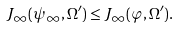Convert formula to latex. <formula><loc_0><loc_0><loc_500><loc_500>J _ { \infty } ( \psi _ { \infty } , \Omega ^ { \prime } ) \leq J _ { \infty } ( \varphi , \Omega ^ { \prime } ) .</formula> 